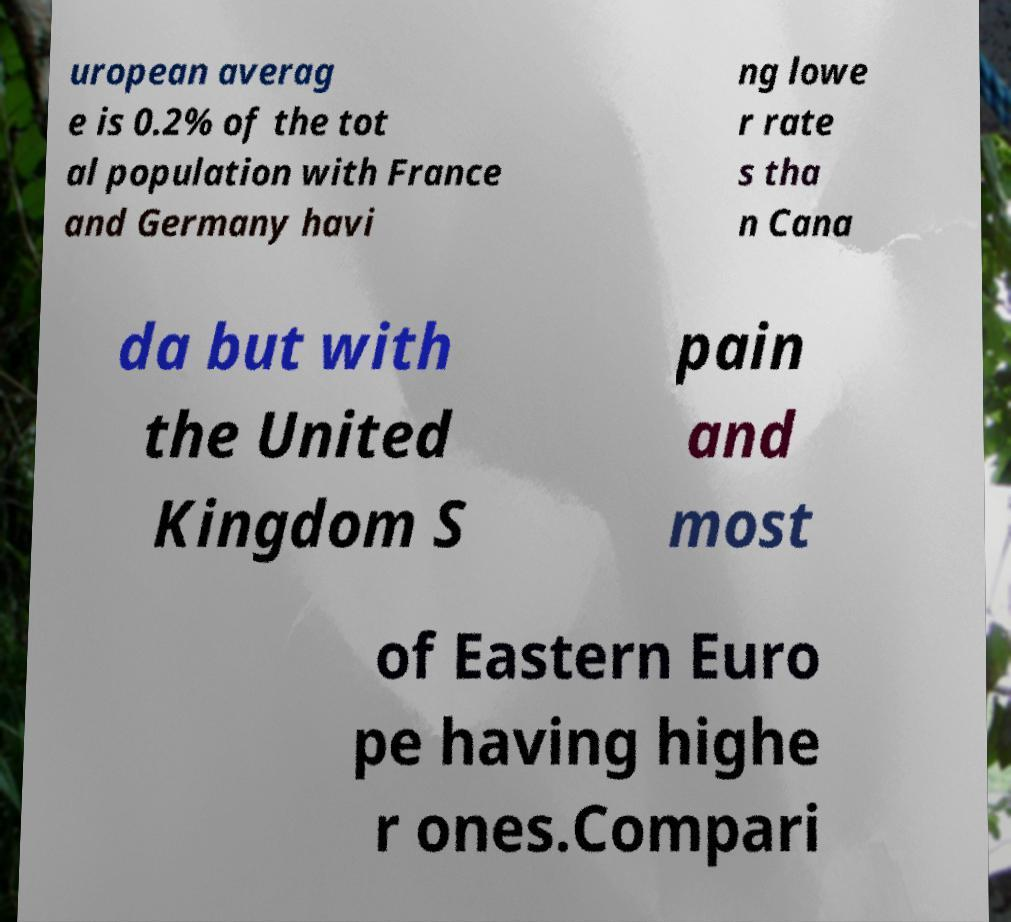For documentation purposes, I need the text within this image transcribed. Could you provide that? uropean averag e is 0.2% of the tot al population with France and Germany havi ng lowe r rate s tha n Cana da but with the United Kingdom S pain and most of Eastern Euro pe having highe r ones.Compari 